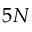<formula> <loc_0><loc_0><loc_500><loc_500>5 N</formula> 